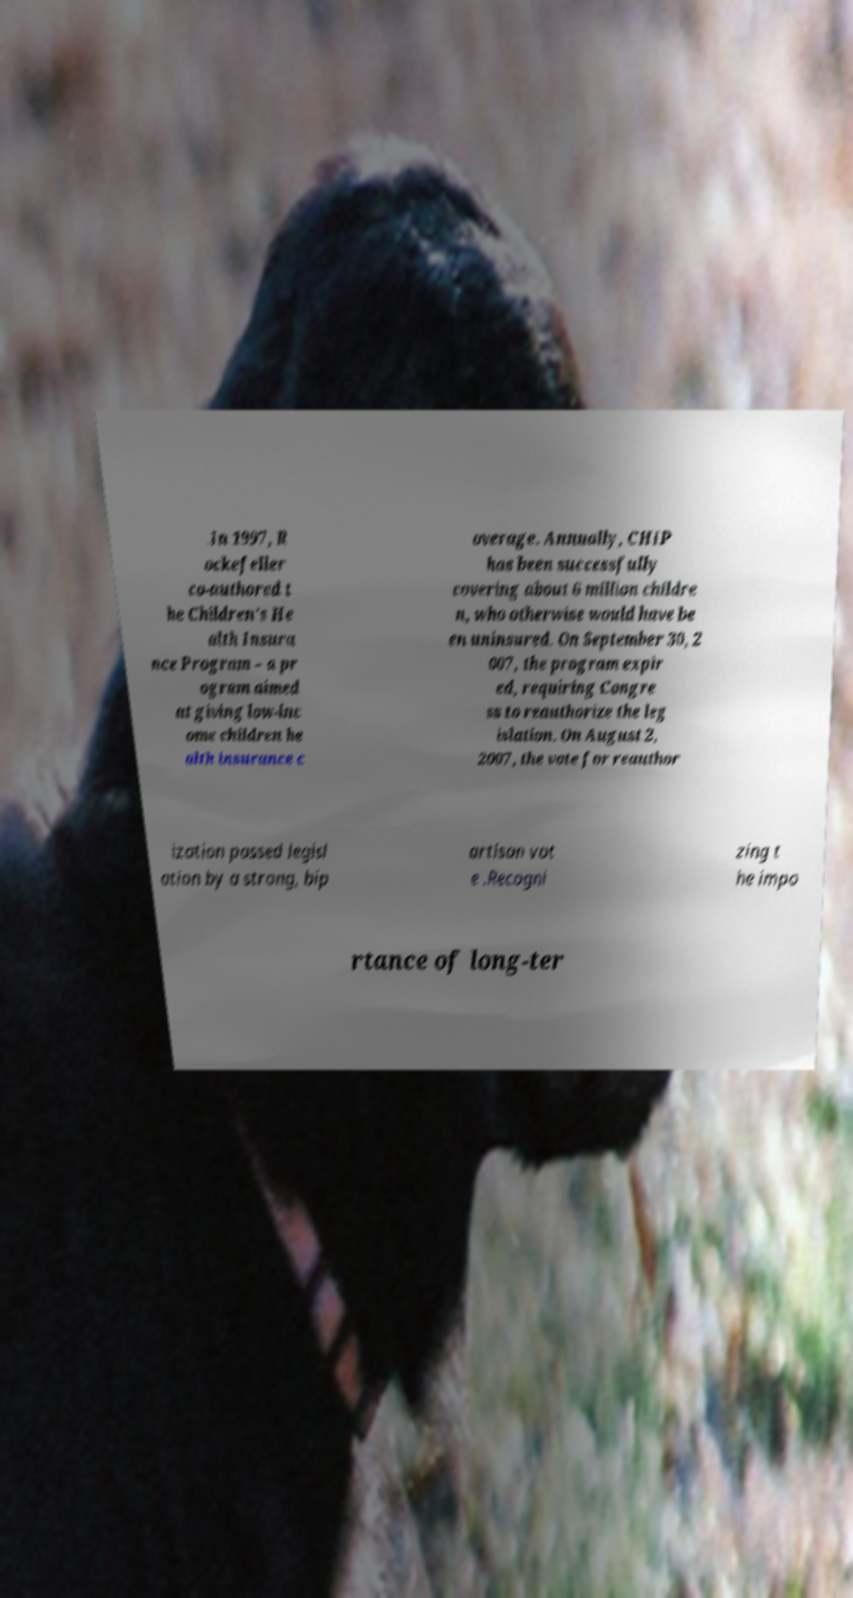Could you assist in decoding the text presented in this image and type it out clearly? .In 1997, R ockefeller co-authored t he Children's He alth Insura nce Program – a pr ogram aimed at giving low-inc ome children he alth insurance c overage. Annually, CHIP has been successfully covering about 6 million childre n, who otherwise would have be en uninsured. On September 30, 2 007, the program expir ed, requiring Congre ss to reauthorize the leg islation. On August 2, 2007, the vote for reauthor ization passed legisl ation by a strong, bip artisan vot e .Recogni zing t he impo rtance of long-ter 